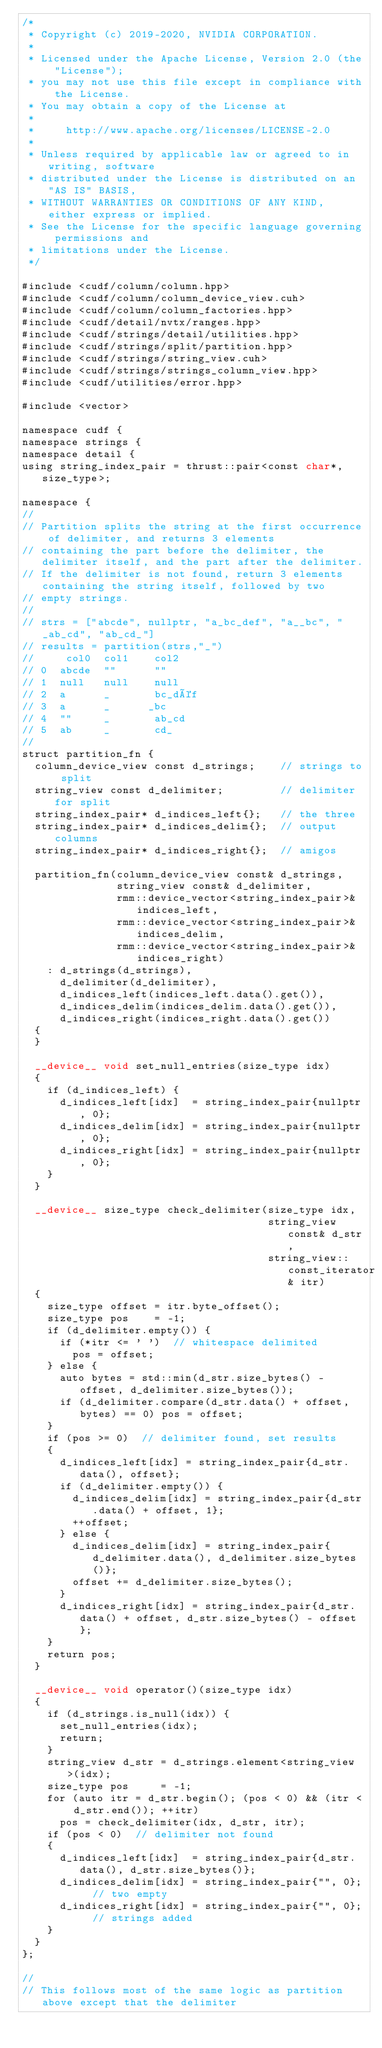<code> <loc_0><loc_0><loc_500><loc_500><_Cuda_>/*
 * Copyright (c) 2019-2020, NVIDIA CORPORATION.
 *
 * Licensed under the Apache License, Version 2.0 (the "License");
 * you may not use this file except in compliance with the License.
 * You may obtain a copy of the License at
 *
 *     http://www.apache.org/licenses/LICENSE-2.0
 *
 * Unless required by applicable law or agreed to in writing, software
 * distributed under the License is distributed on an "AS IS" BASIS,
 * WITHOUT WARRANTIES OR CONDITIONS OF ANY KIND, either express or implied.
 * See the License for the specific language governing permissions and
 * limitations under the License.
 */

#include <cudf/column/column.hpp>
#include <cudf/column/column_device_view.cuh>
#include <cudf/column/column_factories.hpp>
#include <cudf/detail/nvtx/ranges.hpp>
#include <cudf/strings/detail/utilities.hpp>
#include <cudf/strings/split/partition.hpp>
#include <cudf/strings/string_view.cuh>
#include <cudf/strings/strings_column_view.hpp>
#include <cudf/utilities/error.hpp>

#include <vector>

namespace cudf {
namespace strings {
namespace detail {
using string_index_pair = thrust::pair<const char*, size_type>;

namespace {
//
// Partition splits the string at the first occurrence of delimiter, and returns 3 elements
// containing the part before the delimiter, the delimiter itself, and the part after the delimiter.
// If the delimiter is not found, return 3 elements containing the string itself, followed by two
// empty strings.
//
// strs = ["abcde", nullptr, "a_bc_def", "a__bc", "_ab_cd", "ab_cd_"]
// results = partition(strs,"_")
//     col0  col1    col2
// 0  abcde  ""      ""
// 1  null   null    null
// 2  a      _       bc_déf
// 3  a      _      _bc
// 4  ""     _       ab_cd
// 5  ab     _       cd_
//
struct partition_fn {
  column_device_view const d_strings;    // strings to split
  string_view const d_delimiter;         // delimiter for split
  string_index_pair* d_indices_left{};   // the three
  string_index_pair* d_indices_delim{};  // output columns
  string_index_pair* d_indices_right{};  // amigos

  partition_fn(column_device_view const& d_strings,
               string_view const& d_delimiter,
               rmm::device_vector<string_index_pair>& indices_left,
               rmm::device_vector<string_index_pair>& indices_delim,
               rmm::device_vector<string_index_pair>& indices_right)
    : d_strings(d_strings),
      d_delimiter(d_delimiter),
      d_indices_left(indices_left.data().get()),
      d_indices_delim(indices_delim.data().get()),
      d_indices_right(indices_right.data().get())
  {
  }

  __device__ void set_null_entries(size_type idx)
  {
    if (d_indices_left) {
      d_indices_left[idx]  = string_index_pair{nullptr, 0};
      d_indices_delim[idx] = string_index_pair{nullptr, 0};
      d_indices_right[idx] = string_index_pair{nullptr, 0};
    }
  }

  __device__ size_type check_delimiter(size_type idx,
                                       string_view const& d_str,
                                       string_view::const_iterator& itr)
  {
    size_type offset = itr.byte_offset();
    size_type pos    = -1;
    if (d_delimiter.empty()) {
      if (*itr <= ' ')  // whitespace delimited
        pos = offset;
    } else {
      auto bytes = std::min(d_str.size_bytes() - offset, d_delimiter.size_bytes());
      if (d_delimiter.compare(d_str.data() + offset, bytes) == 0) pos = offset;
    }
    if (pos >= 0)  // delimiter found, set results
    {
      d_indices_left[idx] = string_index_pair{d_str.data(), offset};
      if (d_delimiter.empty()) {
        d_indices_delim[idx] = string_index_pair{d_str.data() + offset, 1};
        ++offset;
      } else {
        d_indices_delim[idx] = string_index_pair{d_delimiter.data(), d_delimiter.size_bytes()};
        offset += d_delimiter.size_bytes();
      }
      d_indices_right[idx] = string_index_pair{d_str.data() + offset, d_str.size_bytes() - offset};
    }
    return pos;
  }

  __device__ void operator()(size_type idx)
  {
    if (d_strings.is_null(idx)) {
      set_null_entries(idx);
      return;
    }
    string_view d_str = d_strings.element<string_view>(idx);
    size_type pos     = -1;
    for (auto itr = d_str.begin(); (pos < 0) && (itr < d_str.end()); ++itr)
      pos = check_delimiter(idx, d_str, itr);
    if (pos < 0)  // delimiter not found
    {
      d_indices_left[idx]  = string_index_pair{d_str.data(), d_str.size_bytes()};
      d_indices_delim[idx] = string_index_pair{"", 0};  // two empty
      d_indices_right[idx] = string_index_pair{"", 0};  // strings added
    }
  }
};

//
// This follows most of the same logic as partition above except that the delimiter</code> 